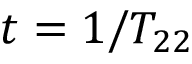<formula> <loc_0><loc_0><loc_500><loc_500>t = 1 / T _ { 2 2 }</formula> 